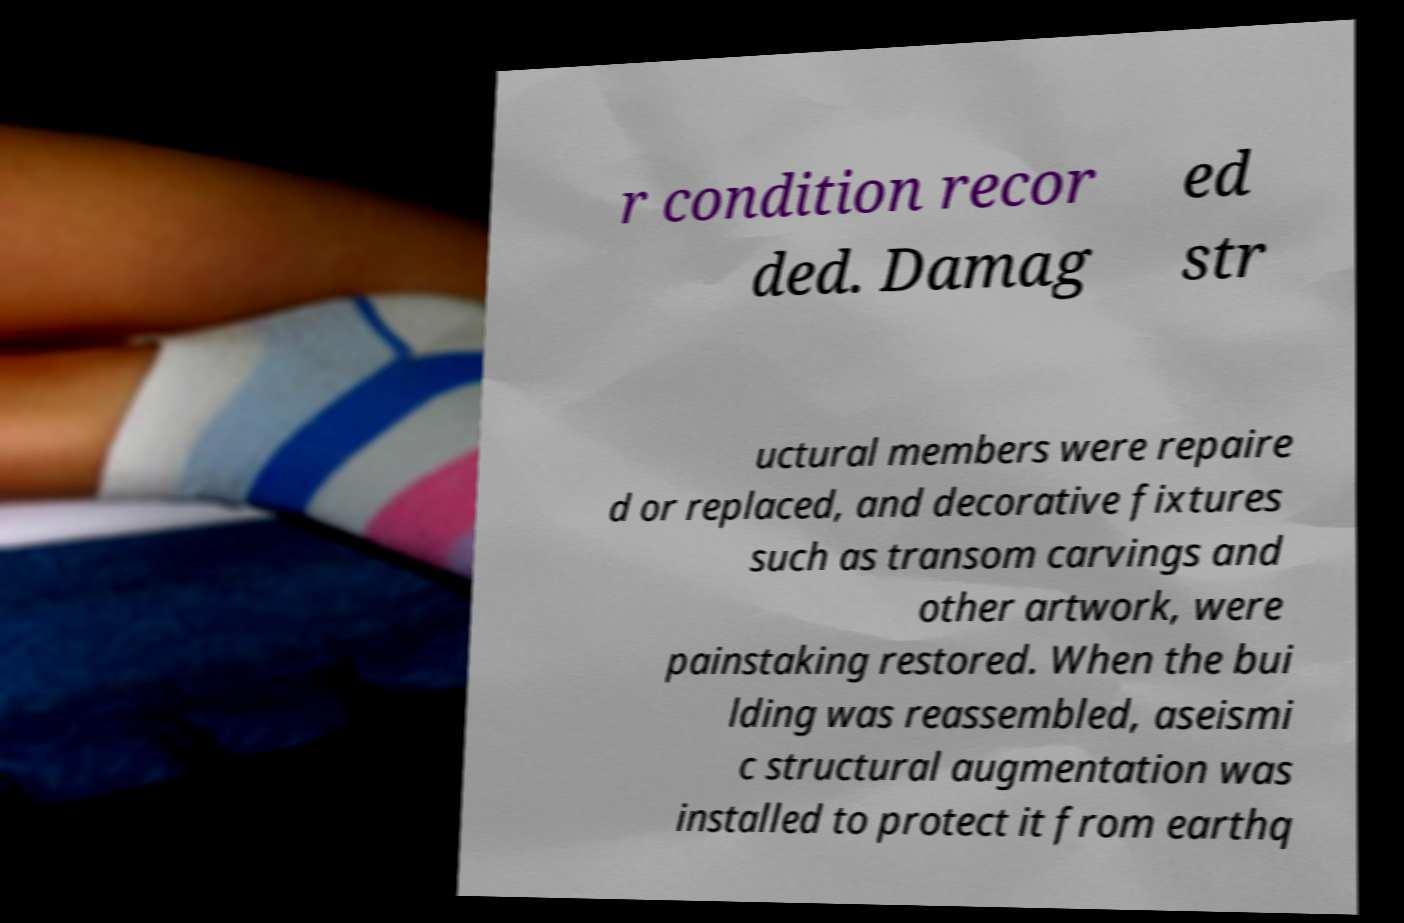I need the written content from this picture converted into text. Can you do that? r condition recor ded. Damag ed str uctural members were repaire d or replaced, and decorative fixtures such as transom carvings and other artwork, were painstaking restored. When the bui lding was reassembled, aseismi c structural augmentation was installed to protect it from earthq 